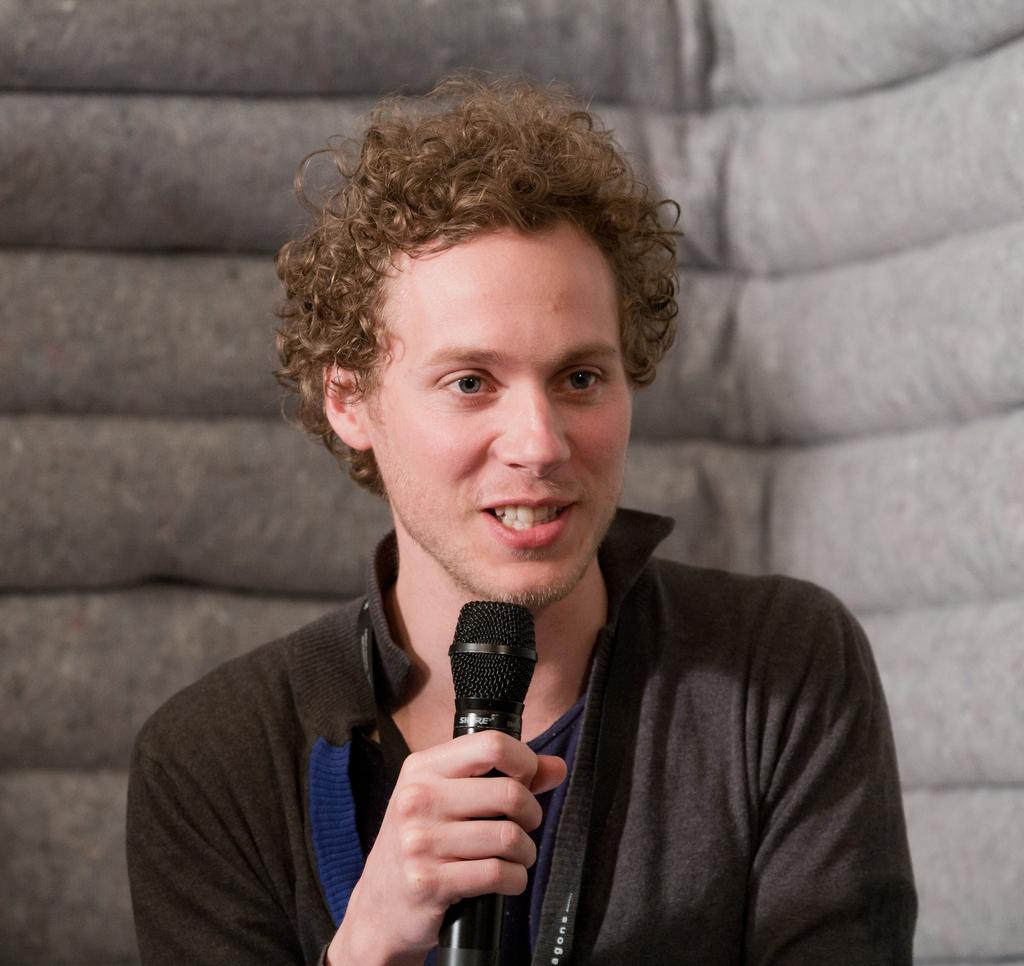Who is present in the image? There is a man in the image. What is the man doing in the image? The man is smiling in the image. What object is the man holding in his hand? The man is holding a mic in his hand. What is the man's profit from the event in the image? There is no information about an event or profit in the image; it only shows a man smiling and holding a mic. 